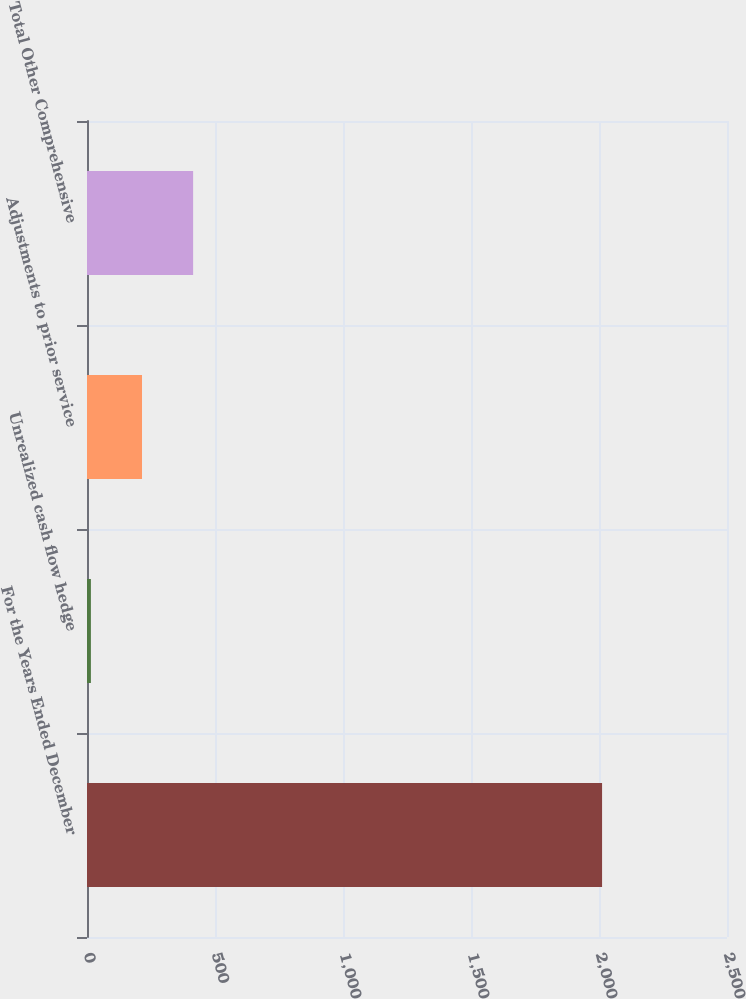Convert chart. <chart><loc_0><loc_0><loc_500><loc_500><bar_chart><fcel>For the Years Ended December<fcel>Unrealized cash flow hedge<fcel>Adjustments to prior service<fcel>Total Other Comprehensive<nl><fcel>2012<fcel>15.2<fcel>214.88<fcel>414.56<nl></chart> 